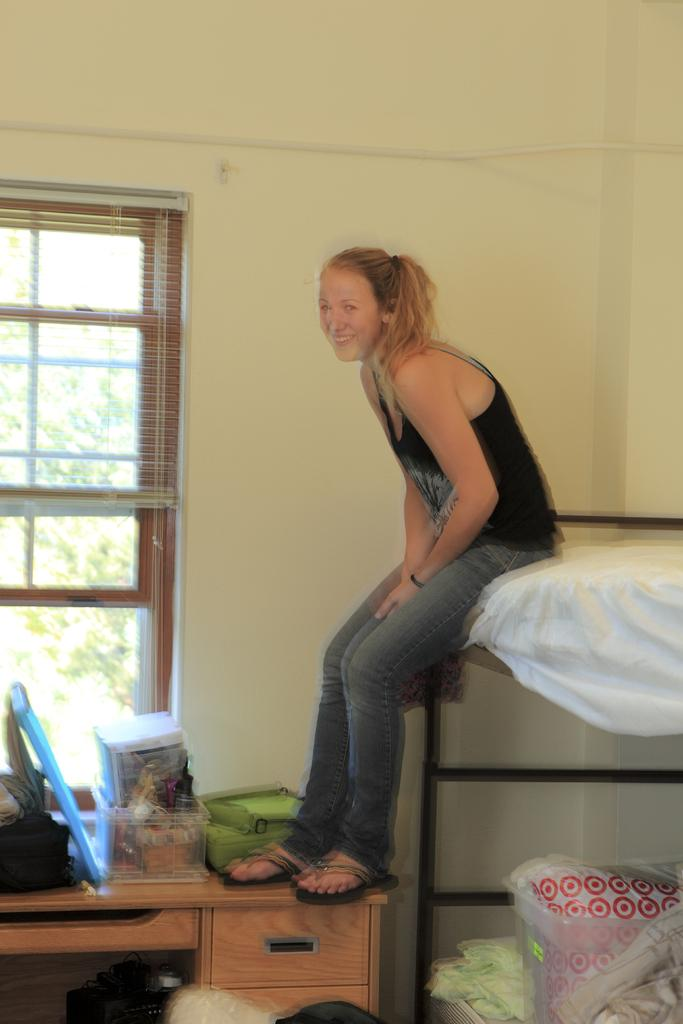What is the woman sitting on in the image? There is a woman sitting on a double cot bed. What is on the bed with the woman? There is a container with clothes on the bed. What furniture is present in the room besides the bed? There is a desk in the room. What objects are on the desk? There is a box and a bag on the desk. What can be seen outside the window in the image? Trees are visible outside the window. What type of ear is visible on the woman in the image? There is no ear visible on the woman in the image. Is there a van parked outside the window in the image? There is no van visible in the image; only trees are visible outside the window. 